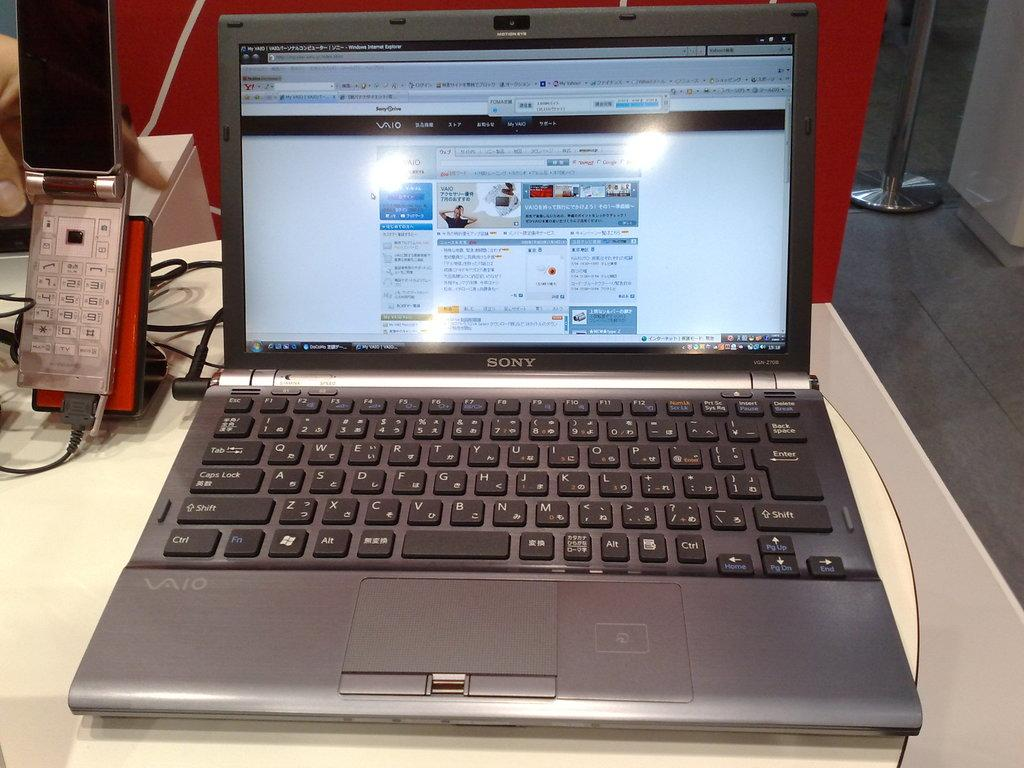<image>
Offer a succinct explanation of the picture presented. a Sony lap top computer open to show a display of colorful images 